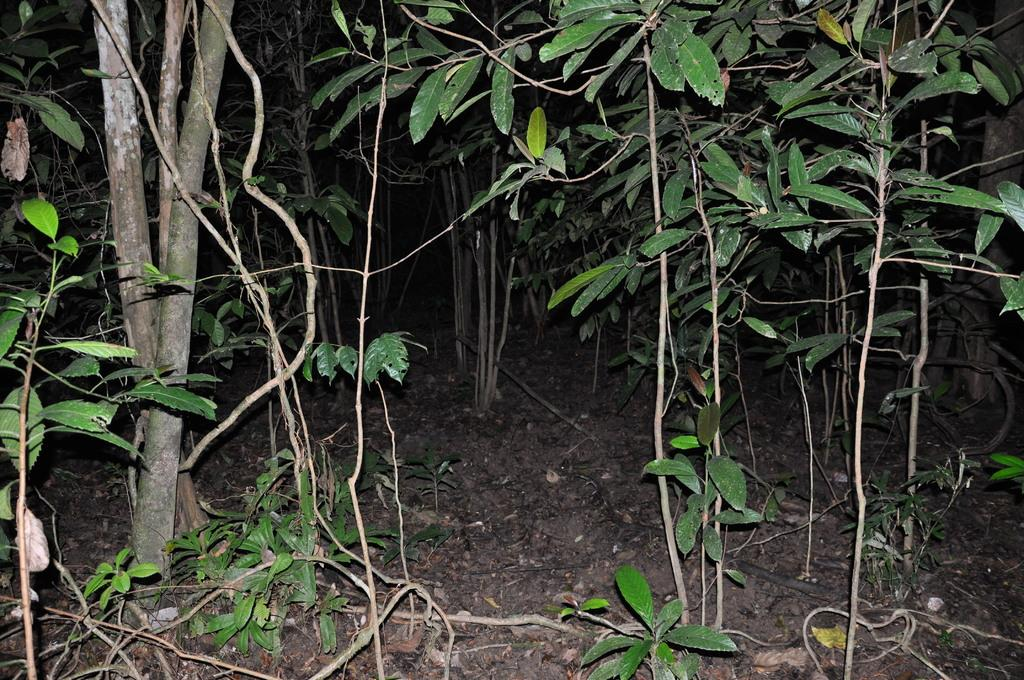What is the main subject of the image? The main subject of the image is a zoomed-in view of plants. What can be observed about the land in the image? The land in the image is brown in color. What is the tendency of the plants to claim territory in the image? There is no indication of the plants claiming territory in the image, as plants do not have the ability to claim territory. 